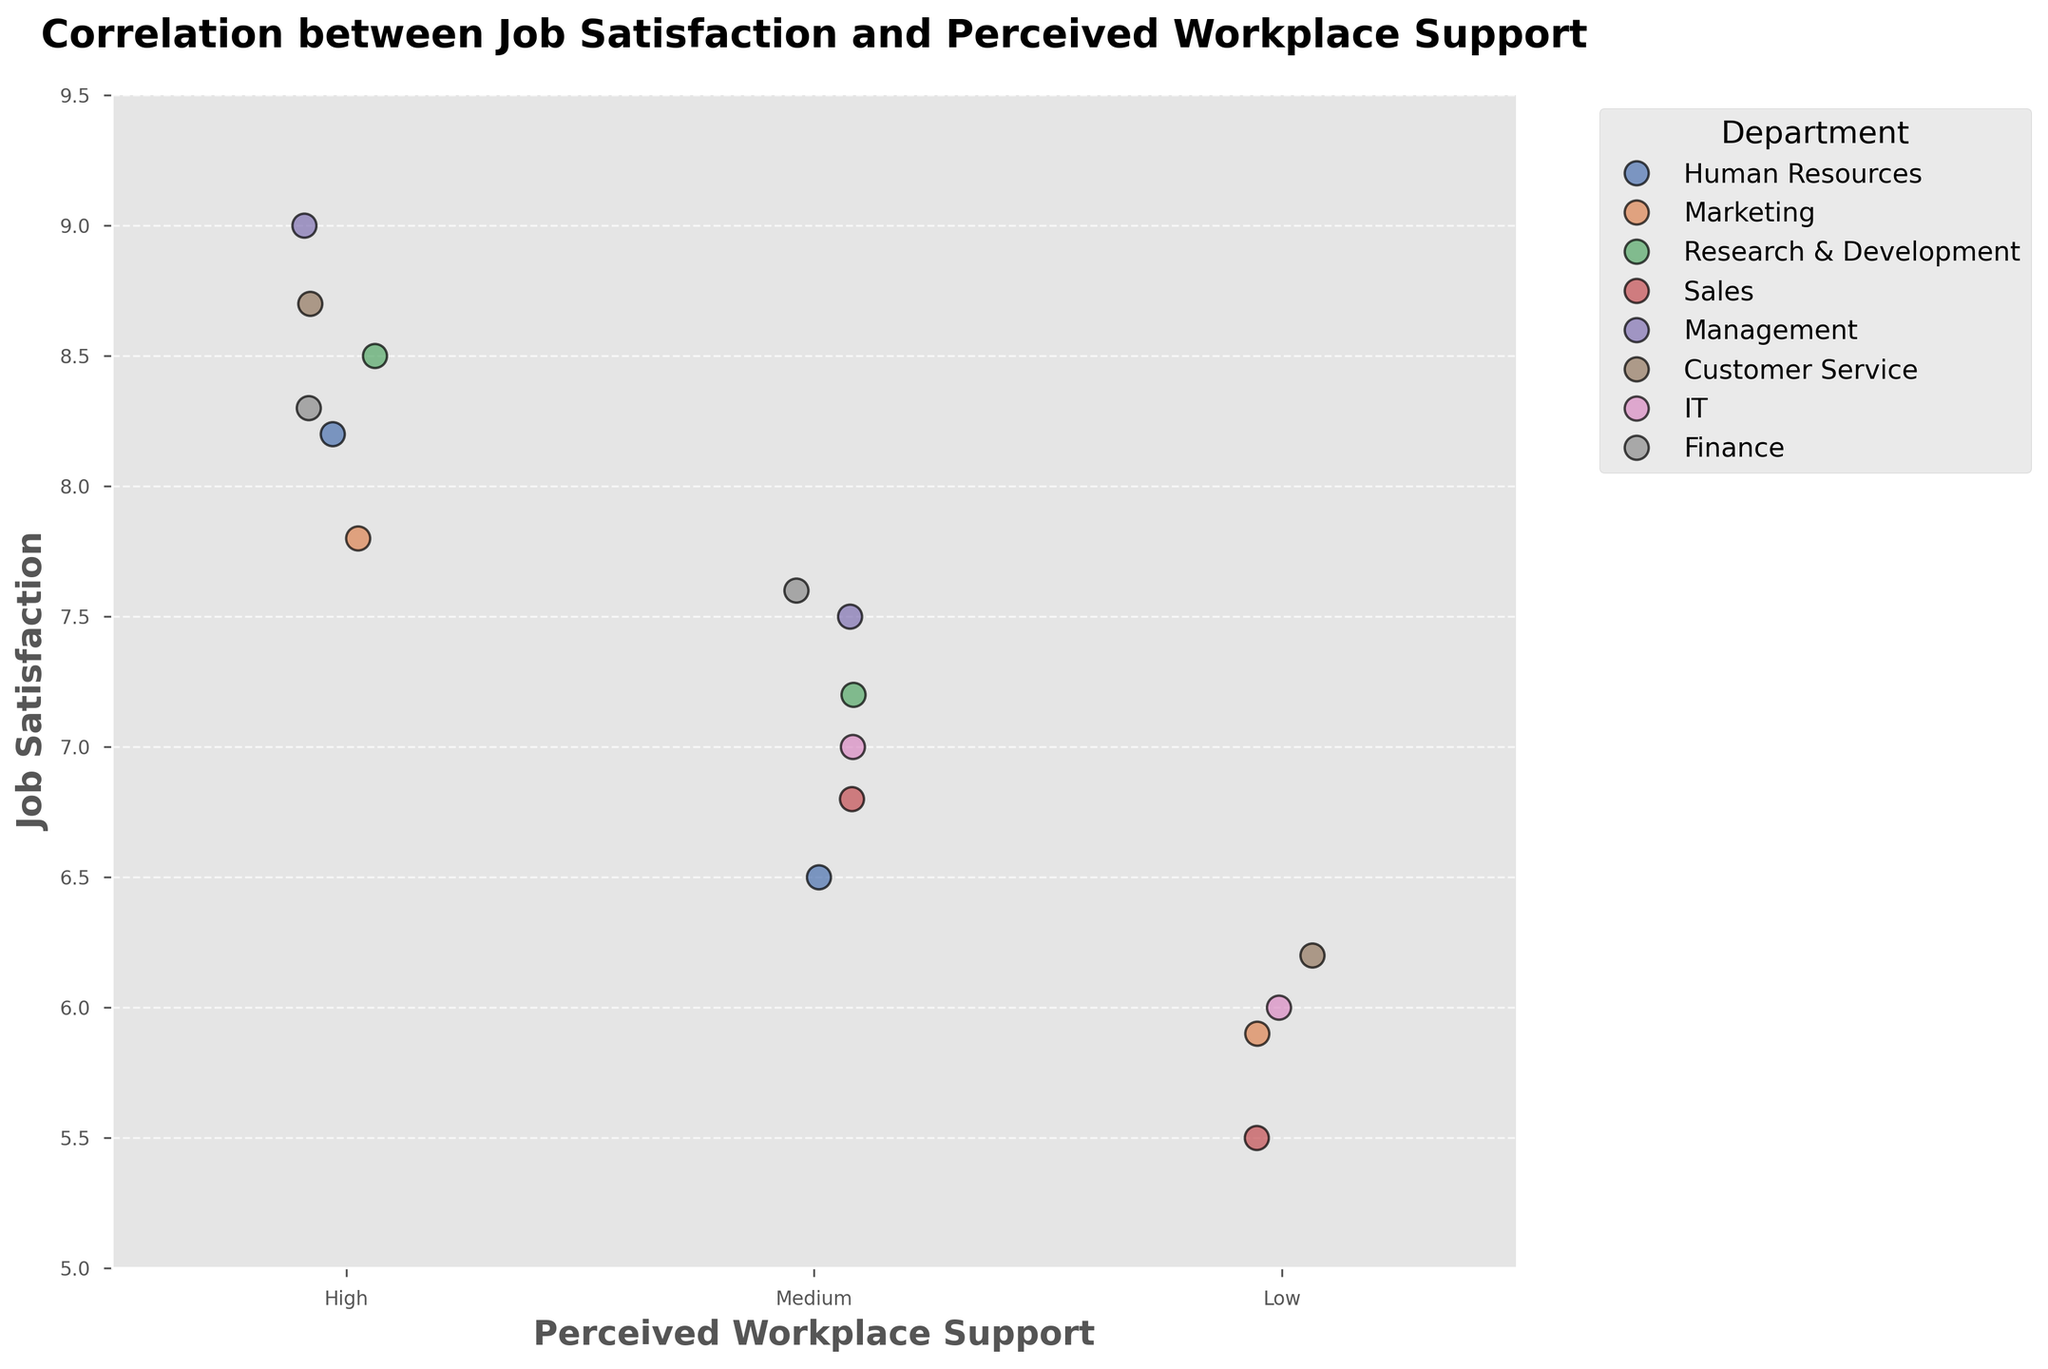What is the title of the figure? The title is usually displayed at the top of the figure. Look for the text at the top that is in a larger and bold font.
Answer: Correlation between Job Satisfaction and Perceived Workplace Support What does the y-axis represent? The y-axis label describes the variable being measured vertically. Look at the text next to the y-axis to find the label.
Answer: Job Satisfaction How many data points are there with "High" perceived workplace support? Count all the points aligned vertically under the "High" label on the x-axis.
Answer: 6 Which department has the data point with the highest job satisfaction? Look for the highest point on the y-axis and check the corresponding color and legend to identify the department.
Answer: Management What is the range of job satisfaction scores for the "Research & Development" department? Identify all points corresponding to "Research & Development" from the legend and note their highest and lowest positions on the y-axis. The range is then the difference between these values.
Answer: 8.5 - 7.2 = 1.3 How does job satisfaction compare between "Low" and "High" perceived workplace support? Compare the vertical positions of the points under "Low" and "High" labels. Higher points indicate higher job satisfaction.
Answer: Higher under "High" Which department has the most variability in job satisfaction scores? Check the spread of points (from lowest to highest) for each department. The most spread out department indicates the most variability.
Answer: Marketing What's the average job satisfaction for departments with "Medium" perceived workplace support? Identify points for "Medium" support, sum their job satisfaction scores, and divide by the number of points.
Answer: (6.5 + 7.2 + 6.8 + 7.5 + 7.0 + 7.6) / 6 = 7.1 How does job satisfaction vary within one department across different levels of perceived workplace support? Choose a department and examine the job satisfaction scores at different levels of workplace support.
Answer: For instance, in IT: 8.5 (High), 7.0 (Medium), 6.0 (Low) 